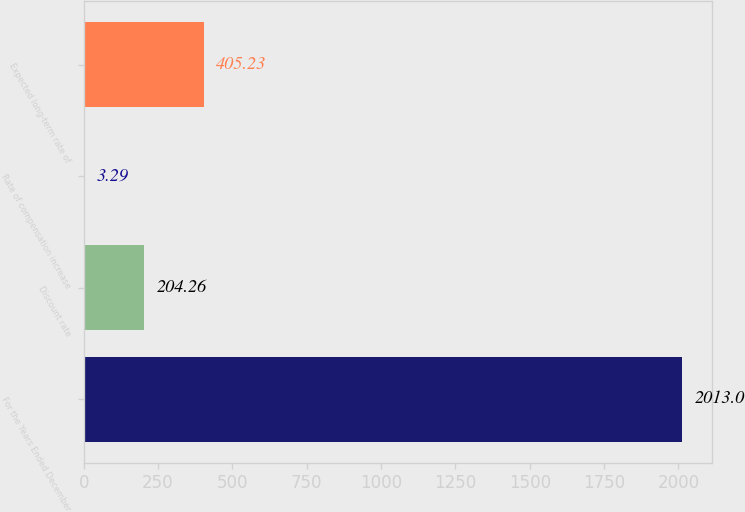<chart> <loc_0><loc_0><loc_500><loc_500><bar_chart><fcel>For the Years Ended December<fcel>Discount rate<fcel>Rate of compensation increase<fcel>Expected long-term rate of<nl><fcel>2013<fcel>204.26<fcel>3.29<fcel>405.23<nl></chart> 